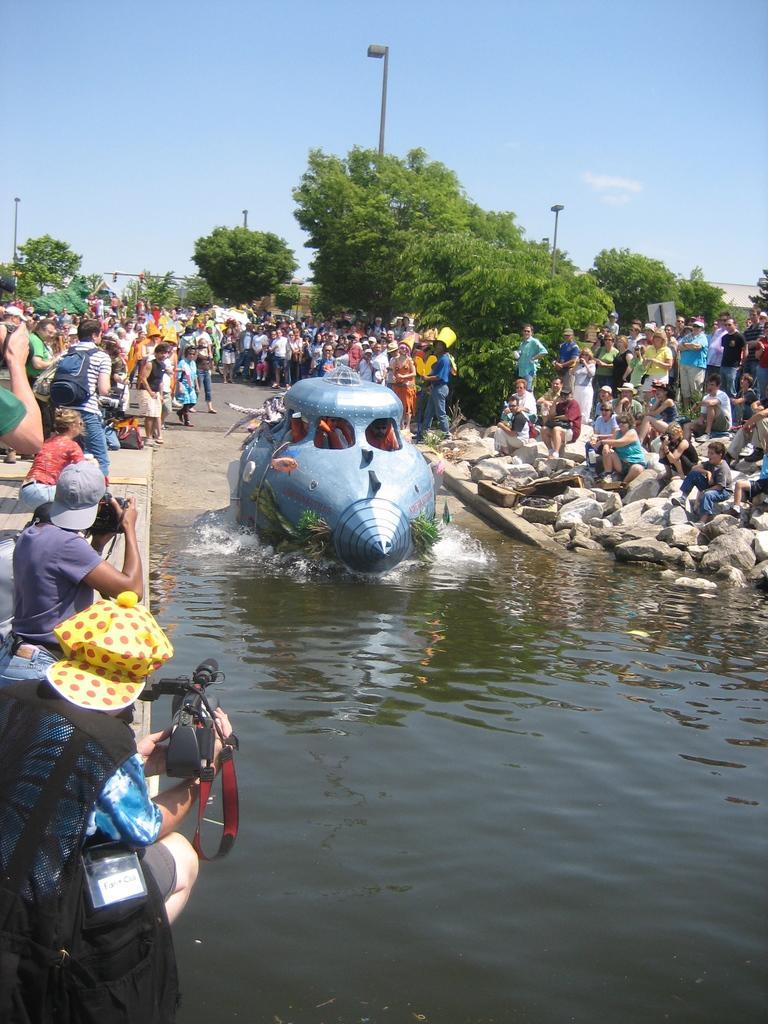Can you describe this image briefly? There is water. On the water there is a boat. There are many people. Some are wearing caps and bags. Also there are some people holding camera. On the right side there are rocks. In the back there are trees, poles and sky. 